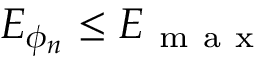<formula> <loc_0><loc_0><loc_500><loc_500>E _ { \phi _ { n } } \leq E _ { m a x }</formula> 